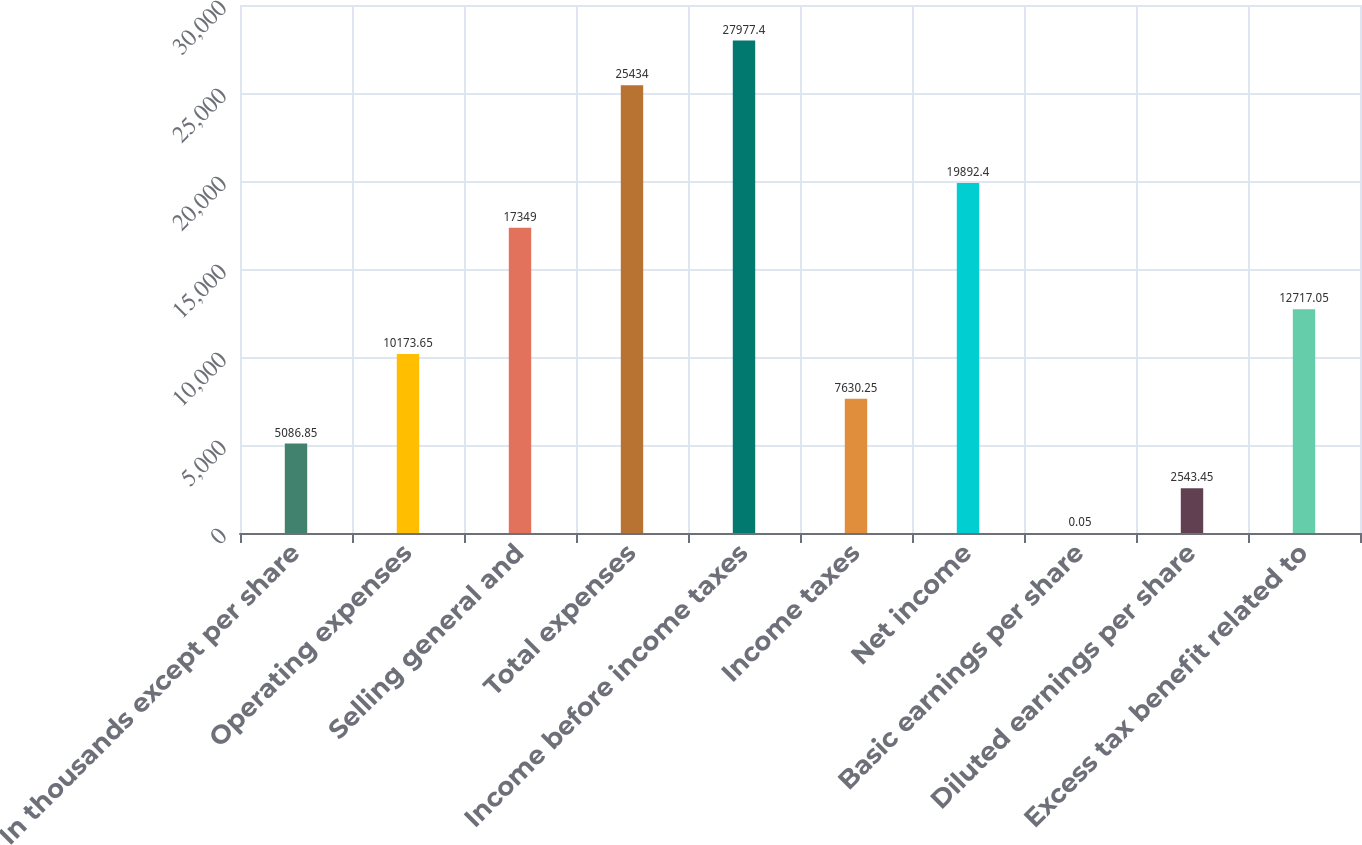Convert chart to OTSL. <chart><loc_0><loc_0><loc_500><loc_500><bar_chart><fcel>In thousands except per share<fcel>Operating expenses<fcel>Selling general and<fcel>Total expenses<fcel>Income before income taxes<fcel>Income taxes<fcel>Net income<fcel>Basic earnings per share<fcel>Diluted earnings per share<fcel>Excess tax benefit related to<nl><fcel>5086.85<fcel>10173.6<fcel>17349<fcel>25434<fcel>27977.4<fcel>7630.25<fcel>19892.4<fcel>0.05<fcel>2543.45<fcel>12717<nl></chart> 